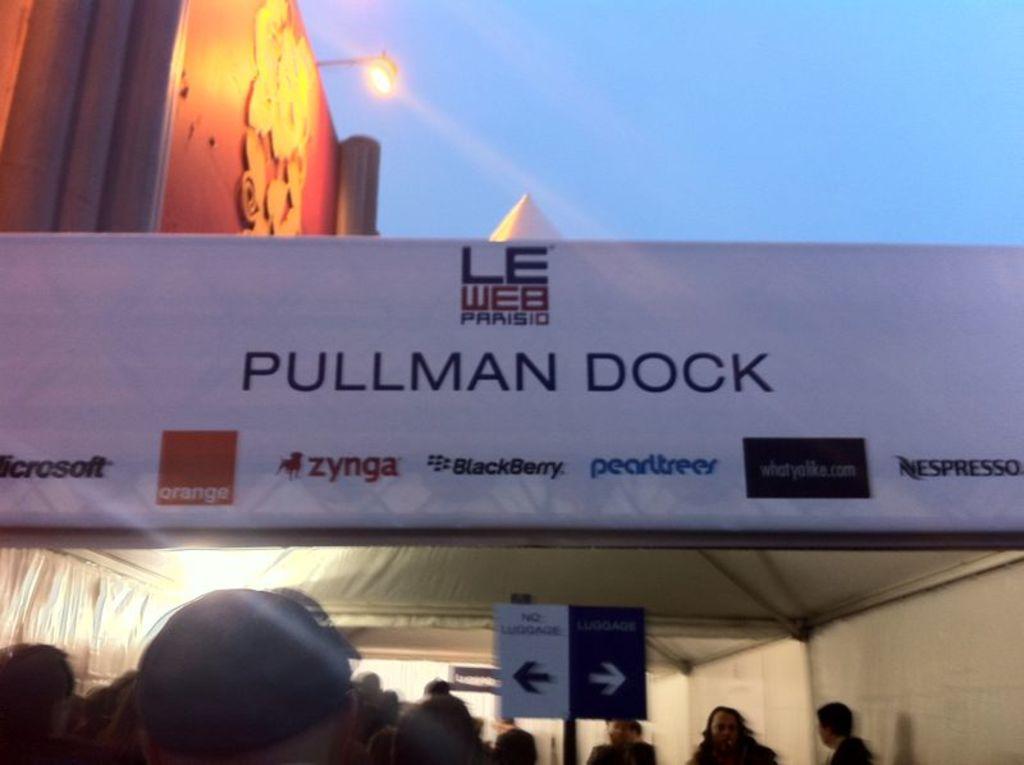What is the name of the dock?
Provide a succinct answer. Pullman. What is one of the sponsors?
Provide a short and direct response. Zynga. 